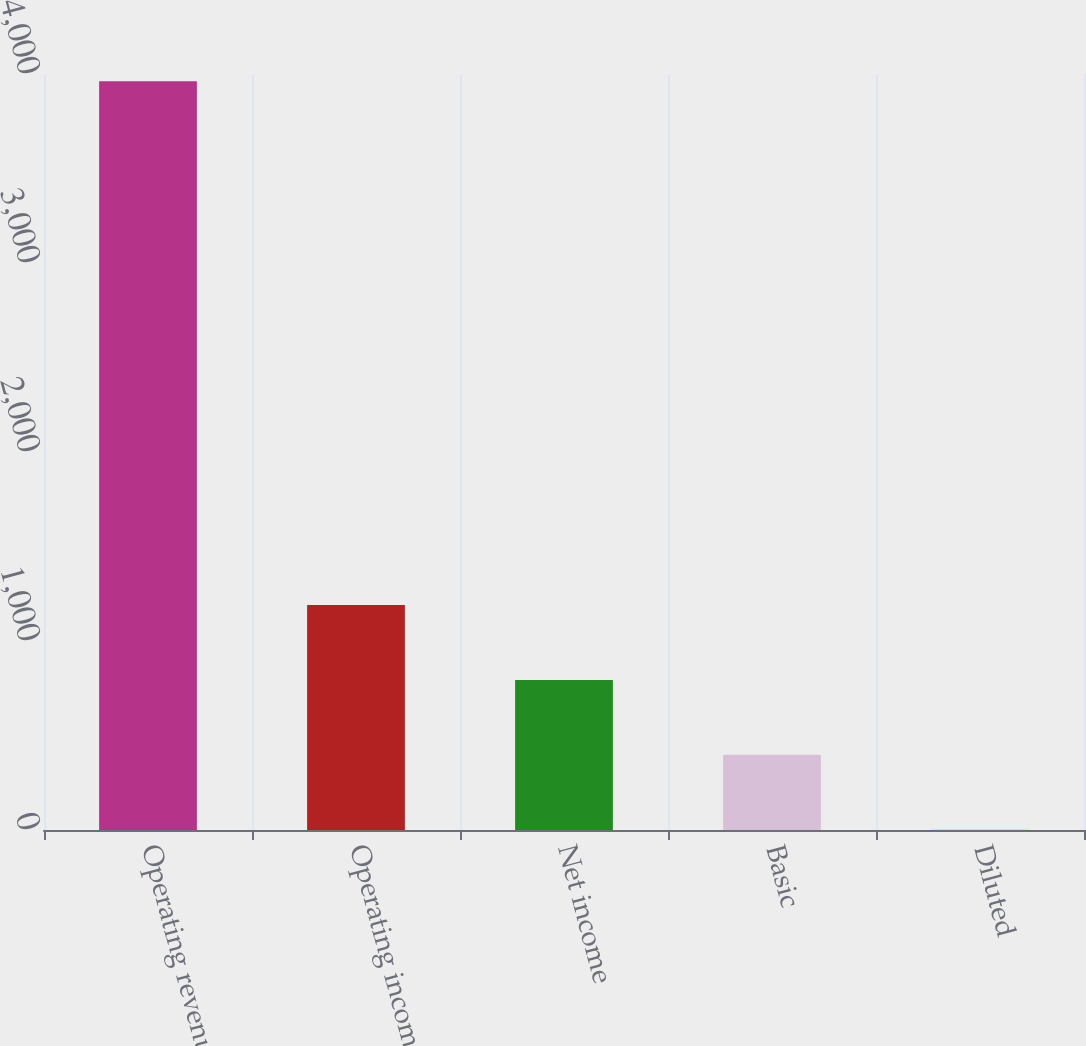Convert chart. <chart><loc_0><loc_0><loc_500><loc_500><bar_chart><fcel>Operating revenue<fcel>Operating income<fcel>Net income<fcel>Basic<fcel>Diluted<nl><fcel>3962<fcel>1189.84<fcel>793.82<fcel>397.8<fcel>1.78<nl></chart> 